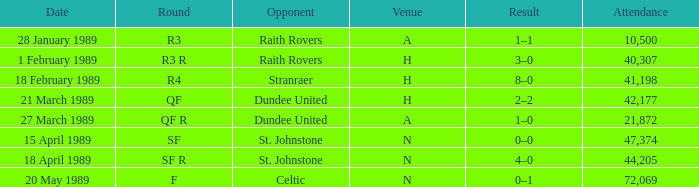What is the date when the round is qf? 21 March 1989. 